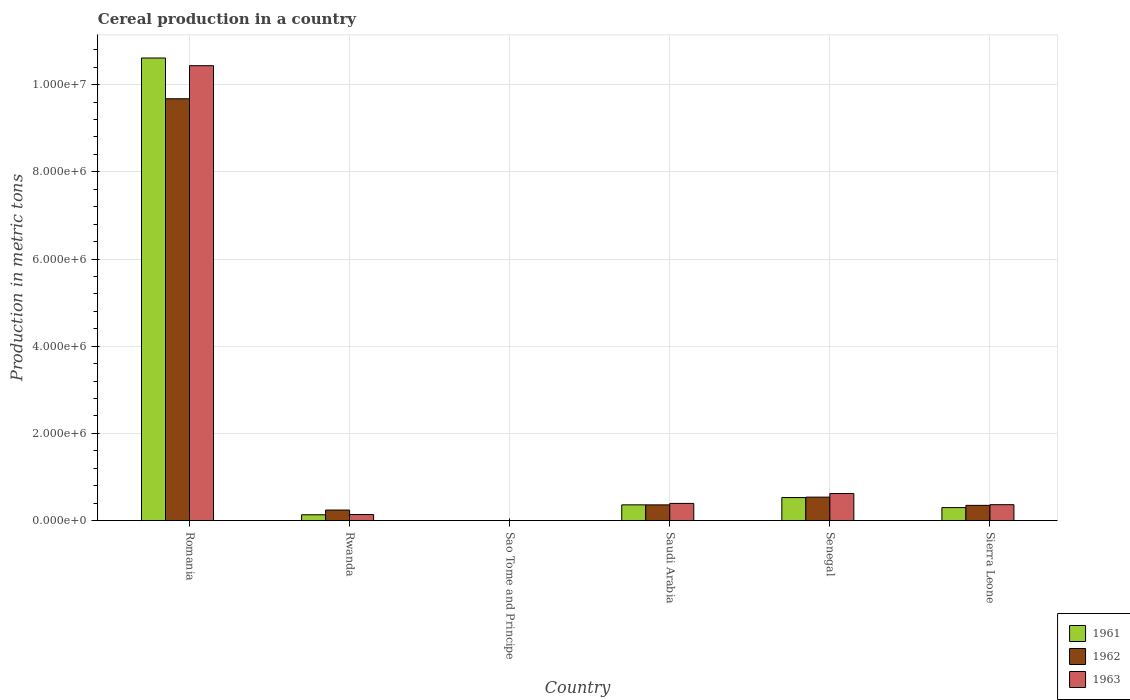How many bars are there on the 4th tick from the right?
Offer a terse response. 3. What is the label of the 5th group of bars from the left?
Ensure brevity in your answer.  Senegal. What is the total cereal production in 1962 in Sierra Leone?
Provide a succinct answer. 3.49e+05. Across all countries, what is the maximum total cereal production in 1963?
Provide a short and direct response. 1.04e+07. In which country was the total cereal production in 1961 maximum?
Provide a succinct answer. Romania. In which country was the total cereal production in 1962 minimum?
Ensure brevity in your answer.  Sao Tome and Principe. What is the total total cereal production in 1963 in the graph?
Your answer should be very brief. 1.20e+07. What is the difference between the total cereal production in 1963 in Rwanda and that in Sierra Leone?
Offer a terse response. -2.26e+05. What is the difference between the total cereal production in 1963 in Sierra Leone and the total cereal production in 1962 in Senegal?
Your answer should be compact. -1.73e+05. What is the average total cereal production in 1962 per country?
Keep it short and to the point. 1.86e+06. What is the difference between the total cereal production of/in 1962 and total cereal production of/in 1961 in Sierra Leone?
Keep it short and to the point. 5.12e+04. In how many countries, is the total cereal production in 1963 greater than 1200000 metric tons?
Your answer should be very brief. 1. What is the ratio of the total cereal production in 1962 in Rwanda to that in Sierra Leone?
Your answer should be compact. 0.69. What is the difference between the highest and the second highest total cereal production in 1962?
Your answer should be compact. 9.32e+06. What is the difference between the highest and the lowest total cereal production in 1962?
Give a very brief answer. 9.68e+06. In how many countries, is the total cereal production in 1963 greater than the average total cereal production in 1963 taken over all countries?
Provide a short and direct response. 1. Is the sum of the total cereal production in 1961 in Romania and Saudi Arabia greater than the maximum total cereal production in 1963 across all countries?
Your response must be concise. Yes. What does the 3rd bar from the left in Senegal represents?
Offer a very short reply. 1963. How many bars are there?
Ensure brevity in your answer.  18. How many countries are there in the graph?
Offer a very short reply. 6. Are the values on the major ticks of Y-axis written in scientific E-notation?
Make the answer very short. Yes. Does the graph contain grids?
Offer a very short reply. Yes. How are the legend labels stacked?
Your response must be concise. Vertical. What is the title of the graph?
Your answer should be very brief. Cereal production in a country. Does "1978" appear as one of the legend labels in the graph?
Ensure brevity in your answer.  No. What is the label or title of the X-axis?
Keep it short and to the point. Country. What is the label or title of the Y-axis?
Your answer should be very brief. Production in metric tons. What is the Production in metric tons in 1961 in Romania?
Your response must be concise. 1.06e+07. What is the Production in metric tons of 1962 in Romania?
Your response must be concise. 9.68e+06. What is the Production in metric tons in 1963 in Romania?
Your answer should be compact. 1.04e+07. What is the Production in metric tons of 1961 in Rwanda?
Offer a terse response. 1.33e+05. What is the Production in metric tons in 1962 in Rwanda?
Your answer should be very brief. 2.41e+05. What is the Production in metric tons of 1963 in Rwanda?
Your response must be concise. 1.39e+05. What is the Production in metric tons of 1963 in Sao Tome and Principe?
Provide a succinct answer. 400. What is the Production in metric tons in 1961 in Saudi Arabia?
Ensure brevity in your answer.  3.61e+05. What is the Production in metric tons of 1962 in Saudi Arabia?
Give a very brief answer. 3.60e+05. What is the Production in metric tons of 1963 in Saudi Arabia?
Your answer should be compact. 3.94e+05. What is the Production in metric tons in 1961 in Senegal?
Provide a succinct answer. 5.28e+05. What is the Production in metric tons of 1962 in Senegal?
Offer a terse response. 5.38e+05. What is the Production in metric tons of 1963 in Senegal?
Ensure brevity in your answer.  6.20e+05. What is the Production in metric tons of 1961 in Sierra Leone?
Offer a terse response. 2.98e+05. What is the Production in metric tons in 1962 in Sierra Leone?
Offer a very short reply. 3.49e+05. What is the Production in metric tons in 1963 in Sierra Leone?
Your answer should be compact. 3.65e+05. Across all countries, what is the maximum Production in metric tons in 1961?
Provide a short and direct response. 1.06e+07. Across all countries, what is the maximum Production in metric tons in 1962?
Make the answer very short. 9.68e+06. Across all countries, what is the maximum Production in metric tons in 1963?
Offer a terse response. 1.04e+07. Across all countries, what is the minimum Production in metric tons in 1961?
Provide a short and direct response. 400. Across all countries, what is the minimum Production in metric tons of 1963?
Offer a very short reply. 400. What is the total Production in metric tons in 1961 in the graph?
Provide a succinct answer. 1.19e+07. What is the total Production in metric tons in 1962 in the graph?
Make the answer very short. 1.12e+07. What is the total Production in metric tons of 1963 in the graph?
Give a very brief answer. 1.20e+07. What is the difference between the Production in metric tons in 1961 in Romania and that in Rwanda?
Ensure brevity in your answer.  1.05e+07. What is the difference between the Production in metric tons of 1962 in Romania and that in Rwanda?
Offer a very short reply. 9.44e+06. What is the difference between the Production in metric tons in 1963 in Romania and that in Rwanda?
Keep it short and to the point. 1.03e+07. What is the difference between the Production in metric tons in 1961 in Romania and that in Sao Tome and Principe?
Your answer should be very brief. 1.06e+07. What is the difference between the Production in metric tons in 1962 in Romania and that in Sao Tome and Principe?
Your answer should be compact. 9.68e+06. What is the difference between the Production in metric tons of 1963 in Romania and that in Sao Tome and Principe?
Offer a terse response. 1.04e+07. What is the difference between the Production in metric tons in 1961 in Romania and that in Saudi Arabia?
Ensure brevity in your answer.  1.03e+07. What is the difference between the Production in metric tons in 1962 in Romania and that in Saudi Arabia?
Keep it short and to the point. 9.32e+06. What is the difference between the Production in metric tons of 1963 in Romania and that in Saudi Arabia?
Provide a succinct answer. 1.00e+07. What is the difference between the Production in metric tons of 1961 in Romania and that in Senegal?
Provide a succinct answer. 1.01e+07. What is the difference between the Production in metric tons of 1962 in Romania and that in Senegal?
Your response must be concise. 9.14e+06. What is the difference between the Production in metric tons in 1963 in Romania and that in Senegal?
Offer a terse response. 9.82e+06. What is the difference between the Production in metric tons in 1961 in Romania and that in Sierra Leone?
Keep it short and to the point. 1.03e+07. What is the difference between the Production in metric tons of 1962 in Romania and that in Sierra Leone?
Your response must be concise. 9.33e+06. What is the difference between the Production in metric tons in 1963 in Romania and that in Sierra Leone?
Offer a very short reply. 1.01e+07. What is the difference between the Production in metric tons of 1961 in Rwanda and that in Sao Tome and Principe?
Make the answer very short. 1.33e+05. What is the difference between the Production in metric tons in 1962 in Rwanda and that in Sao Tome and Principe?
Give a very brief answer. 2.41e+05. What is the difference between the Production in metric tons of 1963 in Rwanda and that in Sao Tome and Principe?
Your response must be concise. 1.39e+05. What is the difference between the Production in metric tons of 1961 in Rwanda and that in Saudi Arabia?
Offer a very short reply. -2.28e+05. What is the difference between the Production in metric tons of 1962 in Rwanda and that in Saudi Arabia?
Make the answer very short. -1.19e+05. What is the difference between the Production in metric tons of 1963 in Rwanda and that in Saudi Arabia?
Your response must be concise. -2.55e+05. What is the difference between the Production in metric tons in 1961 in Rwanda and that in Senegal?
Offer a terse response. -3.95e+05. What is the difference between the Production in metric tons of 1962 in Rwanda and that in Senegal?
Give a very brief answer. -2.97e+05. What is the difference between the Production in metric tons of 1963 in Rwanda and that in Senegal?
Provide a short and direct response. -4.81e+05. What is the difference between the Production in metric tons in 1961 in Rwanda and that in Sierra Leone?
Keep it short and to the point. -1.64e+05. What is the difference between the Production in metric tons of 1962 in Rwanda and that in Sierra Leone?
Your response must be concise. -1.08e+05. What is the difference between the Production in metric tons in 1963 in Rwanda and that in Sierra Leone?
Your response must be concise. -2.26e+05. What is the difference between the Production in metric tons of 1961 in Sao Tome and Principe and that in Saudi Arabia?
Ensure brevity in your answer.  -3.60e+05. What is the difference between the Production in metric tons of 1962 in Sao Tome and Principe and that in Saudi Arabia?
Your response must be concise. -3.60e+05. What is the difference between the Production in metric tons of 1963 in Sao Tome and Principe and that in Saudi Arabia?
Your answer should be compact. -3.93e+05. What is the difference between the Production in metric tons in 1961 in Sao Tome and Principe and that in Senegal?
Your answer should be very brief. -5.28e+05. What is the difference between the Production in metric tons of 1962 in Sao Tome and Principe and that in Senegal?
Make the answer very short. -5.37e+05. What is the difference between the Production in metric tons of 1963 in Sao Tome and Principe and that in Senegal?
Your answer should be very brief. -6.20e+05. What is the difference between the Production in metric tons of 1961 in Sao Tome and Principe and that in Sierra Leone?
Offer a terse response. -2.97e+05. What is the difference between the Production in metric tons in 1962 in Sao Tome and Principe and that in Sierra Leone?
Your answer should be compact. -3.48e+05. What is the difference between the Production in metric tons of 1963 in Sao Tome and Principe and that in Sierra Leone?
Offer a terse response. -3.64e+05. What is the difference between the Production in metric tons of 1961 in Saudi Arabia and that in Senegal?
Your answer should be very brief. -1.67e+05. What is the difference between the Production in metric tons in 1962 in Saudi Arabia and that in Senegal?
Ensure brevity in your answer.  -1.77e+05. What is the difference between the Production in metric tons of 1963 in Saudi Arabia and that in Senegal?
Your response must be concise. -2.27e+05. What is the difference between the Production in metric tons in 1961 in Saudi Arabia and that in Sierra Leone?
Provide a succinct answer. 6.32e+04. What is the difference between the Production in metric tons in 1962 in Saudi Arabia and that in Sierra Leone?
Your response must be concise. 1.15e+04. What is the difference between the Production in metric tons of 1963 in Saudi Arabia and that in Sierra Leone?
Your answer should be compact. 2.89e+04. What is the difference between the Production in metric tons of 1961 in Senegal and that in Sierra Leone?
Your answer should be very brief. 2.30e+05. What is the difference between the Production in metric tons in 1962 in Senegal and that in Sierra Leone?
Offer a very short reply. 1.89e+05. What is the difference between the Production in metric tons of 1963 in Senegal and that in Sierra Leone?
Your response must be concise. 2.55e+05. What is the difference between the Production in metric tons in 1961 in Romania and the Production in metric tons in 1962 in Rwanda?
Give a very brief answer. 1.04e+07. What is the difference between the Production in metric tons in 1961 in Romania and the Production in metric tons in 1963 in Rwanda?
Offer a very short reply. 1.05e+07. What is the difference between the Production in metric tons of 1962 in Romania and the Production in metric tons of 1963 in Rwanda?
Give a very brief answer. 9.54e+06. What is the difference between the Production in metric tons in 1961 in Romania and the Production in metric tons in 1962 in Sao Tome and Principe?
Your response must be concise. 1.06e+07. What is the difference between the Production in metric tons of 1961 in Romania and the Production in metric tons of 1963 in Sao Tome and Principe?
Give a very brief answer. 1.06e+07. What is the difference between the Production in metric tons in 1962 in Romania and the Production in metric tons in 1963 in Sao Tome and Principe?
Provide a succinct answer. 9.68e+06. What is the difference between the Production in metric tons of 1961 in Romania and the Production in metric tons of 1962 in Saudi Arabia?
Provide a short and direct response. 1.03e+07. What is the difference between the Production in metric tons of 1961 in Romania and the Production in metric tons of 1963 in Saudi Arabia?
Offer a terse response. 1.02e+07. What is the difference between the Production in metric tons in 1962 in Romania and the Production in metric tons in 1963 in Saudi Arabia?
Your response must be concise. 9.28e+06. What is the difference between the Production in metric tons of 1961 in Romania and the Production in metric tons of 1962 in Senegal?
Ensure brevity in your answer.  1.01e+07. What is the difference between the Production in metric tons of 1961 in Romania and the Production in metric tons of 1963 in Senegal?
Offer a terse response. 9.99e+06. What is the difference between the Production in metric tons of 1962 in Romania and the Production in metric tons of 1963 in Senegal?
Ensure brevity in your answer.  9.06e+06. What is the difference between the Production in metric tons of 1961 in Romania and the Production in metric tons of 1962 in Sierra Leone?
Offer a very short reply. 1.03e+07. What is the difference between the Production in metric tons of 1961 in Romania and the Production in metric tons of 1963 in Sierra Leone?
Make the answer very short. 1.02e+07. What is the difference between the Production in metric tons in 1962 in Romania and the Production in metric tons in 1963 in Sierra Leone?
Offer a terse response. 9.31e+06. What is the difference between the Production in metric tons of 1961 in Rwanda and the Production in metric tons of 1962 in Sao Tome and Principe?
Make the answer very short. 1.33e+05. What is the difference between the Production in metric tons in 1961 in Rwanda and the Production in metric tons in 1963 in Sao Tome and Principe?
Make the answer very short. 1.33e+05. What is the difference between the Production in metric tons of 1962 in Rwanda and the Production in metric tons of 1963 in Sao Tome and Principe?
Your answer should be compact. 2.41e+05. What is the difference between the Production in metric tons of 1961 in Rwanda and the Production in metric tons of 1962 in Saudi Arabia?
Your answer should be compact. -2.27e+05. What is the difference between the Production in metric tons of 1961 in Rwanda and the Production in metric tons of 1963 in Saudi Arabia?
Provide a succinct answer. -2.60e+05. What is the difference between the Production in metric tons of 1962 in Rwanda and the Production in metric tons of 1963 in Saudi Arabia?
Your response must be concise. -1.52e+05. What is the difference between the Production in metric tons of 1961 in Rwanda and the Production in metric tons of 1962 in Senegal?
Keep it short and to the point. -4.05e+05. What is the difference between the Production in metric tons of 1961 in Rwanda and the Production in metric tons of 1963 in Senegal?
Offer a terse response. -4.87e+05. What is the difference between the Production in metric tons of 1962 in Rwanda and the Production in metric tons of 1963 in Senegal?
Ensure brevity in your answer.  -3.79e+05. What is the difference between the Production in metric tons in 1961 in Rwanda and the Production in metric tons in 1962 in Sierra Leone?
Your answer should be very brief. -2.16e+05. What is the difference between the Production in metric tons in 1961 in Rwanda and the Production in metric tons in 1963 in Sierra Leone?
Keep it short and to the point. -2.32e+05. What is the difference between the Production in metric tons in 1962 in Rwanda and the Production in metric tons in 1963 in Sierra Leone?
Offer a very short reply. -1.24e+05. What is the difference between the Production in metric tons in 1961 in Sao Tome and Principe and the Production in metric tons in 1962 in Saudi Arabia?
Keep it short and to the point. -3.60e+05. What is the difference between the Production in metric tons in 1961 in Sao Tome and Principe and the Production in metric tons in 1963 in Saudi Arabia?
Keep it short and to the point. -3.93e+05. What is the difference between the Production in metric tons of 1962 in Sao Tome and Principe and the Production in metric tons of 1963 in Saudi Arabia?
Provide a succinct answer. -3.93e+05. What is the difference between the Production in metric tons in 1961 in Sao Tome and Principe and the Production in metric tons in 1962 in Senegal?
Your response must be concise. -5.37e+05. What is the difference between the Production in metric tons of 1961 in Sao Tome and Principe and the Production in metric tons of 1963 in Senegal?
Your response must be concise. -6.20e+05. What is the difference between the Production in metric tons of 1962 in Sao Tome and Principe and the Production in metric tons of 1963 in Senegal?
Provide a succinct answer. -6.20e+05. What is the difference between the Production in metric tons of 1961 in Sao Tome and Principe and the Production in metric tons of 1962 in Sierra Leone?
Your answer should be compact. -3.48e+05. What is the difference between the Production in metric tons of 1961 in Sao Tome and Principe and the Production in metric tons of 1963 in Sierra Leone?
Your response must be concise. -3.64e+05. What is the difference between the Production in metric tons of 1962 in Sao Tome and Principe and the Production in metric tons of 1963 in Sierra Leone?
Give a very brief answer. -3.64e+05. What is the difference between the Production in metric tons of 1961 in Saudi Arabia and the Production in metric tons of 1962 in Senegal?
Ensure brevity in your answer.  -1.77e+05. What is the difference between the Production in metric tons of 1961 in Saudi Arabia and the Production in metric tons of 1963 in Senegal?
Offer a terse response. -2.60e+05. What is the difference between the Production in metric tons of 1962 in Saudi Arabia and the Production in metric tons of 1963 in Senegal?
Your answer should be compact. -2.60e+05. What is the difference between the Production in metric tons in 1961 in Saudi Arabia and the Production in metric tons in 1962 in Sierra Leone?
Give a very brief answer. 1.19e+04. What is the difference between the Production in metric tons of 1961 in Saudi Arabia and the Production in metric tons of 1963 in Sierra Leone?
Your answer should be very brief. -4087. What is the difference between the Production in metric tons of 1962 in Saudi Arabia and the Production in metric tons of 1963 in Sierra Leone?
Give a very brief answer. -4567. What is the difference between the Production in metric tons in 1961 in Senegal and the Production in metric tons in 1962 in Sierra Leone?
Your response must be concise. 1.79e+05. What is the difference between the Production in metric tons of 1961 in Senegal and the Production in metric tons of 1963 in Sierra Leone?
Your answer should be compact. 1.63e+05. What is the difference between the Production in metric tons of 1962 in Senegal and the Production in metric tons of 1963 in Sierra Leone?
Provide a succinct answer. 1.73e+05. What is the average Production in metric tons in 1961 per country?
Your response must be concise. 1.99e+06. What is the average Production in metric tons in 1962 per country?
Make the answer very short. 1.86e+06. What is the average Production in metric tons in 1963 per country?
Your response must be concise. 1.99e+06. What is the difference between the Production in metric tons in 1961 and Production in metric tons in 1962 in Romania?
Your answer should be compact. 9.35e+05. What is the difference between the Production in metric tons of 1961 and Production in metric tons of 1963 in Romania?
Give a very brief answer. 1.76e+05. What is the difference between the Production in metric tons in 1962 and Production in metric tons in 1963 in Romania?
Your answer should be compact. -7.59e+05. What is the difference between the Production in metric tons of 1961 and Production in metric tons of 1962 in Rwanda?
Offer a very short reply. -1.08e+05. What is the difference between the Production in metric tons of 1961 and Production in metric tons of 1963 in Rwanda?
Ensure brevity in your answer.  -5637. What is the difference between the Production in metric tons of 1962 and Production in metric tons of 1963 in Rwanda?
Provide a short and direct response. 1.02e+05. What is the difference between the Production in metric tons in 1961 and Production in metric tons in 1963 in Sao Tome and Principe?
Your response must be concise. 0. What is the difference between the Production in metric tons in 1961 and Production in metric tons in 1962 in Saudi Arabia?
Give a very brief answer. 480. What is the difference between the Production in metric tons of 1961 and Production in metric tons of 1963 in Saudi Arabia?
Offer a terse response. -3.29e+04. What is the difference between the Production in metric tons of 1962 and Production in metric tons of 1963 in Saudi Arabia?
Offer a terse response. -3.34e+04. What is the difference between the Production in metric tons of 1961 and Production in metric tons of 1962 in Senegal?
Your answer should be compact. -9687. What is the difference between the Production in metric tons in 1961 and Production in metric tons in 1963 in Senegal?
Your response must be concise. -9.22e+04. What is the difference between the Production in metric tons of 1962 and Production in metric tons of 1963 in Senegal?
Give a very brief answer. -8.25e+04. What is the difference between the Production in metric tons of 1961 and Production in metric tons of 1962 in Sierra Leone?
Your response must be concise. -5.12e+04. What is the difference between the Production in metric tons in 1961 and Production in metric tons in 1963 in Sierra Leone?
Make the answer very short. -6.73e+04. What is the difference between the Production in metric tons in 1962 and Production in metric tons in 1963 in Sierra Leone?
Make the answer very short. -1.60e+04. What is the ratio of the Production in metric tons of 1961 in Romania to that in Rwanda?
Make the answer very short. 79.62. What is the ratio of the Production in metric tons in 1962 in Romania to that in Rwanda?
Provide a short and direct response. 40.11. What is the ratio of the Production in metric tons of 1963 in Romania to that in Rwanda?
Provide a short and direct response. 75.12. What is the ratio of the Production in metric tons in 1961 in Romania to that in Sao Tome and Principe?
Make the answer very short. 2.65e+04. What is the ratio of the Production in metric tons in 1962 in Romania to that in Sao Tome and Principe?
Your response must be concise. 2.42e+04. What is the ratio of the Production in metric tons of 1963 in Romania to that in Sao Tome and Principe?
Give a very brief answer. 2.61e+04. What is the ratio of the Production in metric tons in 1961 in Romania to that in Saudi Arabia?
Keep it short and to the point. 29.41. What is the ratio of the Production in metric tons of 1962 in Romania to that in Saudi Arabia?
Your answer should be very brief. 26.86. What is the ratio of the Production in metric tons of 1963 in Romania to that in Saudi Arabia?
Your answer should be compact. 26.5. What is the ratio of the Production in metric tons in 1961 in Romania to that in Senegal?
Your answer should be very brief. 20.09. What is the ratio of the Production in metric tons of 1962 in Romania to that in Senegal?
Ensure brevity in your answer.  17.99. What is the ratio of the Production in metric tons of 1963 in Romania to that in Senegal?
Give a very brief answer. 16.82. What is the ratio of the Production in metric tons in 1961 in Romania to that in Sierra Leone?
Provide a succinct answer. 35.66. What is the ratio of the Production in metric tons of 1962 in Romania to that in Sierra Leone?
Provide a succinct answer. 27.74. What is the ratio of the Production in metric tons in 1963 in Romania to that in Sierra Leone?
Make the answer very short. 28.6. What is the ratio of the Production in metric tons in 1961 in Rwanda to that in Sao Tome and Principe?
Keep it short and to the point. 333.23. What is the ratio of the Production in metric tons of 1962 in Rwanda to that in Sao Tome and Principe?
Offer a very short reply. 603.22. What is the ratio of the Production in metric tons of 1963 in Rwanda to that in Sao Tome and Principe?
Your response must be concise. 347.32. What is the ratio of the Production in metric tons in 1961 in Rwanda to that in Saudi Arabia?
Your response must be concise. 0.37. What is the ratio of the Production in metric tons in 1962 in Rwanda to that in Saudi Arabia?
Your response must be concise. 0.67. What is the ratio of the Production in metric tons of 1963 in Rwanda to that in Saudi Arabia?
Your answer should be compact. 0.35. What is the ratio of the Production in metric tons in 1961 in Rwanda to that in Senegal?
Ensure brevity in your answer.  0.25. What is the ratio of the Production in metric tons in 1962 in Rwanda to that in Senegal?
Keep it short and to the point. 0.45. What is the ratio of the Production in metric tons of 1963 in Rwanda to that in Senegal?
Keep it short and to the point. 0.22. What is the ratio of the Production in metric tons of 1961 in Rwanda to that in Sierra Leone?
Offer a terse response. 0.45. What is the ratio of the Production in metric tons in 1962 in Rwanda to that in Sierra Leone?
Make the answer very short. 0.69. What is the ratio of the Production in metric tons in 1963 in Rwanda to that in Sierra Leone?
Ensure brevity in your answer.  0.38. What is the ratio of the Production in metric tons of 1961 in Sao Tome and Principe to that in Saudi Arabia?
Make the answer very short. 0. What is the ratio of the Production in metric tons in 1962 in Sao Tome and Principe to that in Saudi Arabia?
Ensure brevity in your answer.  0. What is the ratio of the Production in metric tons of 1963 in Sao Tome and Principe to that in Saudi Arabia?
Provide a short and direct response. 0. What is the ratio of the Production in metric tons of 1961 in Sao Tome and Principe to that in Senegal?
Ensure brevity in your answer.  0. What is the ratio of the Production in metric tons in 1962 in Sao Tome and Principe to that in Senegal?
Keep it short and to the point. 0. What is the ratio of the Production in metric tons of 1963 in Sao Tome and Principe to that in Senegal?
Offer a terse response. 0. What is the ratio of the Production in metric tons in 1961 in Sao Tome and Principe to that in Sierra Leone?
Offer a terse response. 0. What is the ratio of the Production in metric tons in 1962 in Sao Tome and Principe to that in Sierra Leone?
Give a very brief answer. 0. What is the ratio of the Production in metric tons of 1963 in Sao Tome and Principe to that in Sierra Leone?
Your response must be concise. 0. What is the ratio of the Production in metric tons in 1961 in Saudi Arabia to that in Senegal?
Offer a very short reply. 0.68. What is the ratio of the Production in metric tons of 1962 in Saudi Arabia to that in Senegal?
Offer a very short reply. 0.67. What is the ratio of the Production in metric tons of 1963 in Saudi Arabia to that in Senegal?
Your answer should be compact. 0.63. What is the ratio of the Production in metric tons in 1961 in Saudi Arabia to that in Sierra Leone?
Provide a succinct answer. 1.21. What is the ratio of the Production in metric tons of 1962 in Saudi Arabia to that in Sierra Leone?
Your answer should be very brief. 1.03. What is the ratio of the Production in metric tons in 1963 in Saudi Arabia to that in Sierra Leone?
Offer a terse response. 1.08. What is the ratio of the Production in metric tons of 1961 in Senegal to that in Sierra Leone?
Provide a short and direct response. 1.77. What is the ratio of the Production in metric tons of 1962 in Senegal to that in Sierra Leone?
Provide a short and direct response. 1.54. What is the difference between the highest and the second highest Production in metric tons of 1961?
Keep it short and to the point. 1.01e+07. What is the difference between the highest and the second highest Production in metric tons in 1962?
Your response must be concise. 9.14e+06. What is the difference between the highest and the second highest Production in metric tons of 1963?
Your answer should be very brief. 9.82e+06. What is the difference between the highest and the lowest Production in metric tons in 1961?
Your answer should be compact. 1.06e+07. What is the difference between the highest and the lowest Production in metric tons in 1962?
Your answer should be very brief. 9.68e+06. What is the difference between the highest and the lowest Production in metric tons of 1963?
Give a very brief answer. 1.04e+07. 